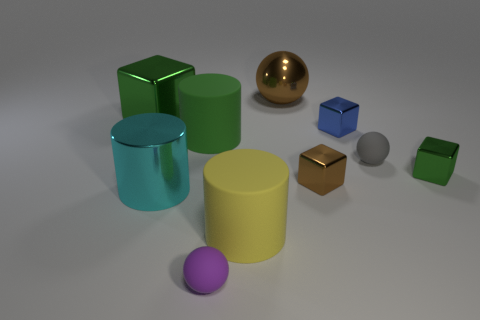Subtract 1 cubes. How many cubes are left? 3 Subtract all cylinders. How many objects are left? 7 Add 9 large purple objects. How many large purple objects exist? 9 Subtract 0 red blocks. How many objects are left? 10 Subtract all gray matte things. Subtract all purple metallic things. How many objects are left? 9 Add 2 balls. How many balls are left? 5 